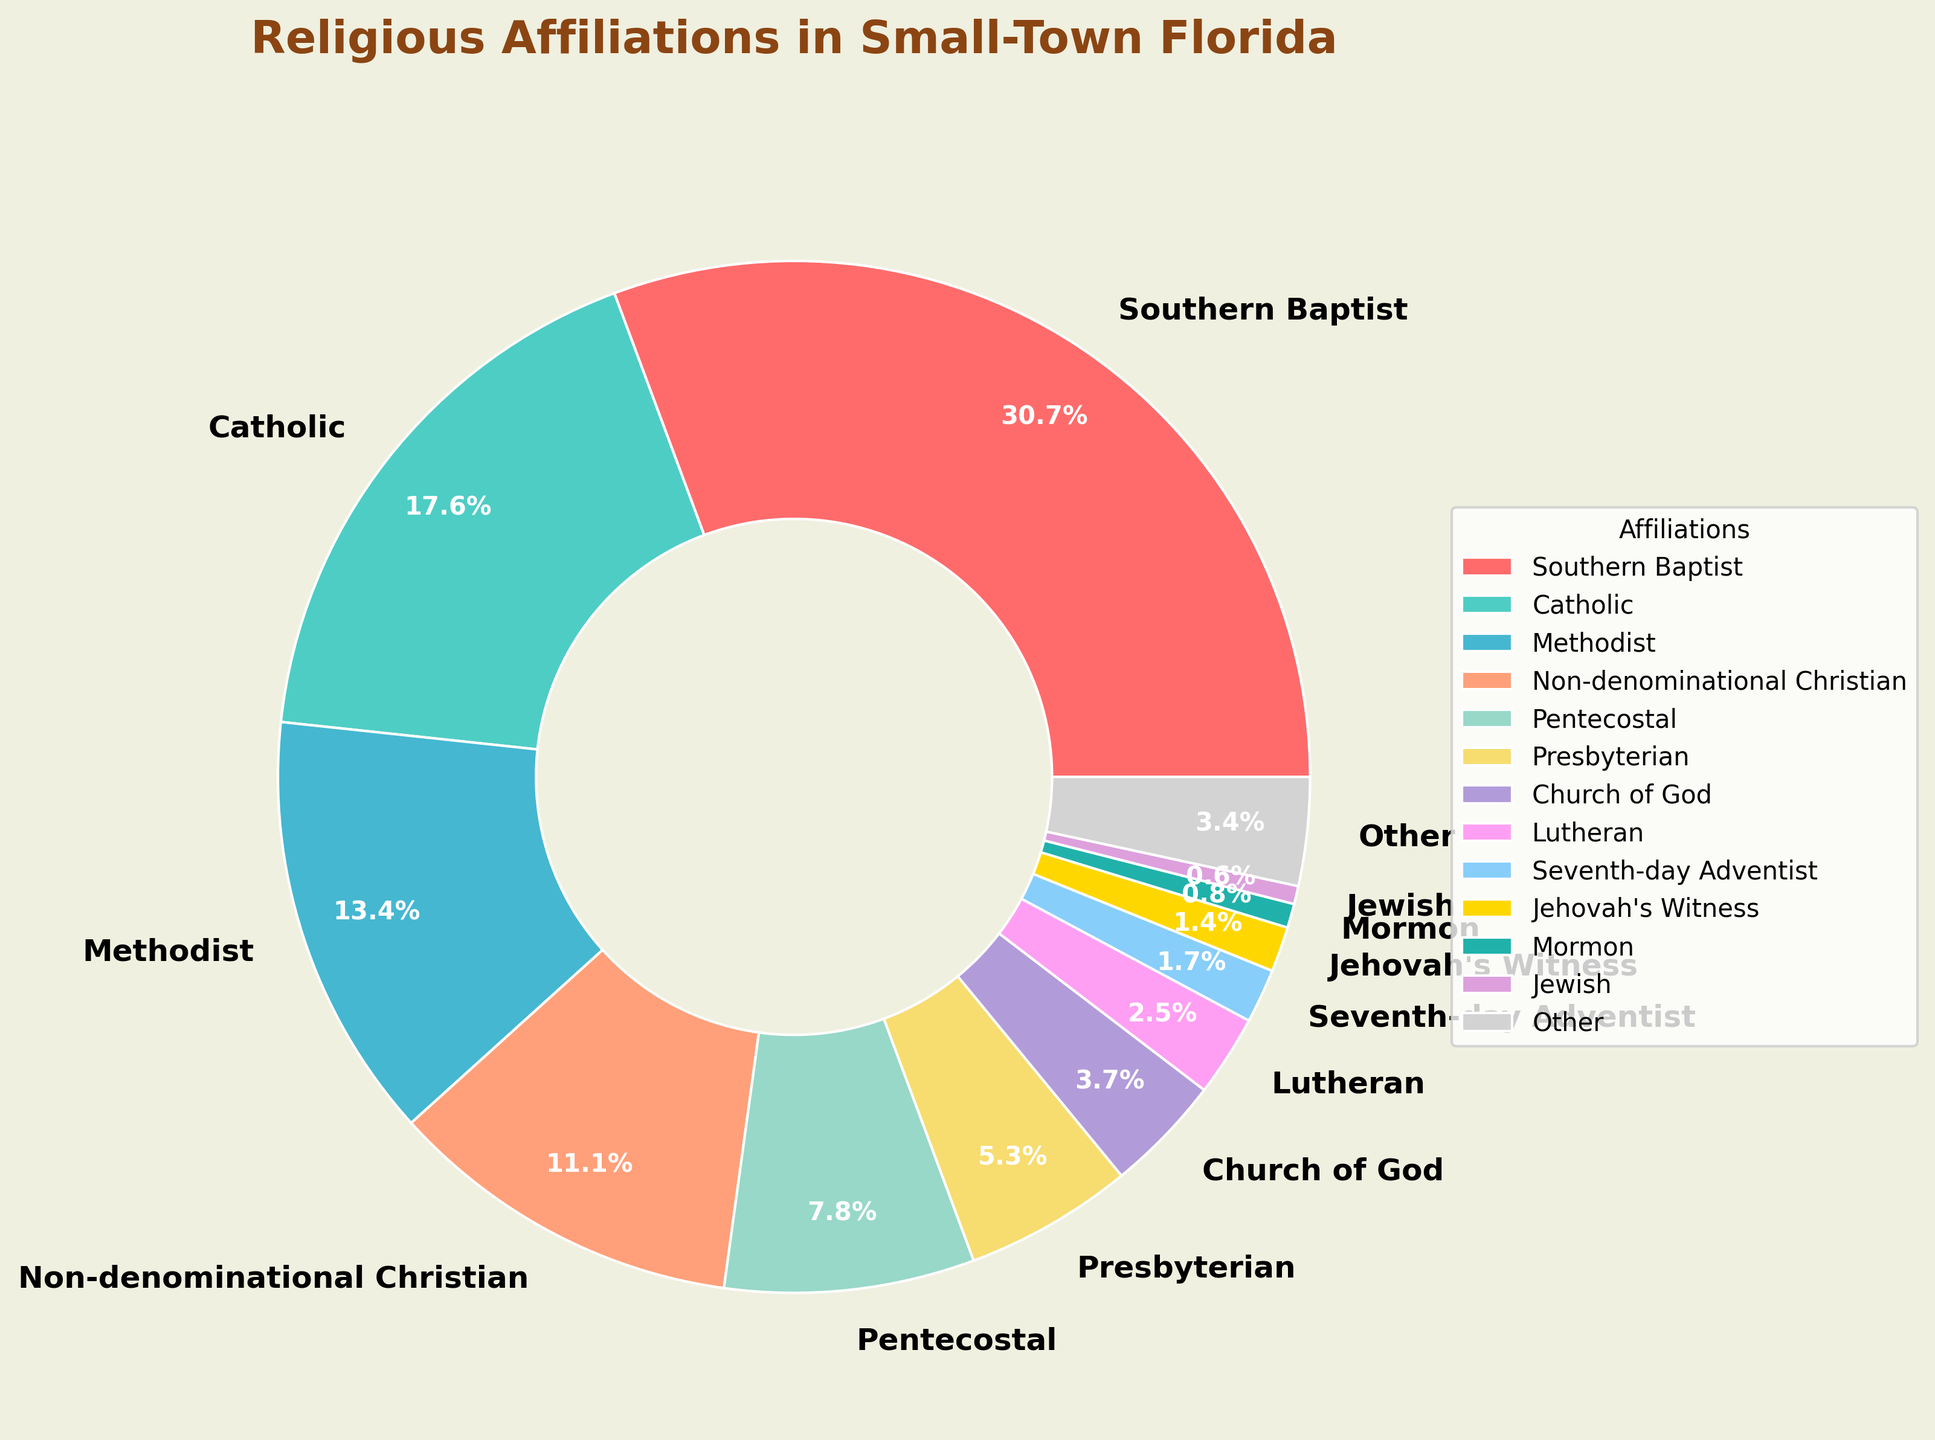What's the largest religious affiliation in the chart? The largest religious affiliation can be identified by finding the segment with the highest percentage. In this chart, the Southern Baptist percentage is the largest at 32.5%.
Answer: Southern Baptist Which religious affiliation has the smallest percentage? The smallest percentage can be identified by looking at the segment with the lowest value on the chart. The Mormon affiliation has the smallest percentage at 0.8%.
Answer: Mormon What is the combined percentage of Catholic and Methodist affiliations? By summing their individual percentages: Catholic (18.7%) + Methodist (14.2%), we get 18.7 + 14.2 = 32.9.
Answer: 32.9% Are there more Southern Baptists or Catholics? By comparing their percentages, Southern Baptists have 32.5%, while Catholics have 18.7%. 32.5% is greater than 18.7%.
Answer: Southern Baptists What's the difference in percentage between Non-denominational Christian and Pentecostal affiliations? The difference can be calculated by subtracting Pentecostal's percentage from Non-denominational Christian's percentage: 11.8% - 8.3% = 3.5%.
Answer: 3.5% Which two religious affiliations combined are closest to the percentage of the Southern Baptist affiliation? To find the combination closest to 32.5%, we need to look at various pairs and their sums. Catholic (18.7%) + Methodist (14.2%) = 32.9%, which is closest to 32.5%.
Answer: Catholic and Methodist What are the colors representing the Methodist and Jewish affiliations? By observing the chart, the segment representing Methodist is light blue, and the segment for Jewish is purple.
Answer: light blue and purple What is the total percentage of affiliations grouped under "Other"? The percentage labeled as "Other" is 3.6%.
Answer: 3.6% Which religious affiliation is represented by the gold-colored segment? By observing the colors and legends, the gold color represents Jehovah's Witness with a percentage of 1.5%.
Answer: Jehovah's Witness What is the combined percentage of affiliations that make up less than 2% each? The affiliations with less than 2% each are Seventh-day Adventist (1.8%), Jehovah's Witness (1.5%), Mormon (0.8%), and Jewish (0.6%). Summing these percentages: 1.8 + 1.5 + 0.8 + 0.6 = 4.7%.
Answer: 4.7% 